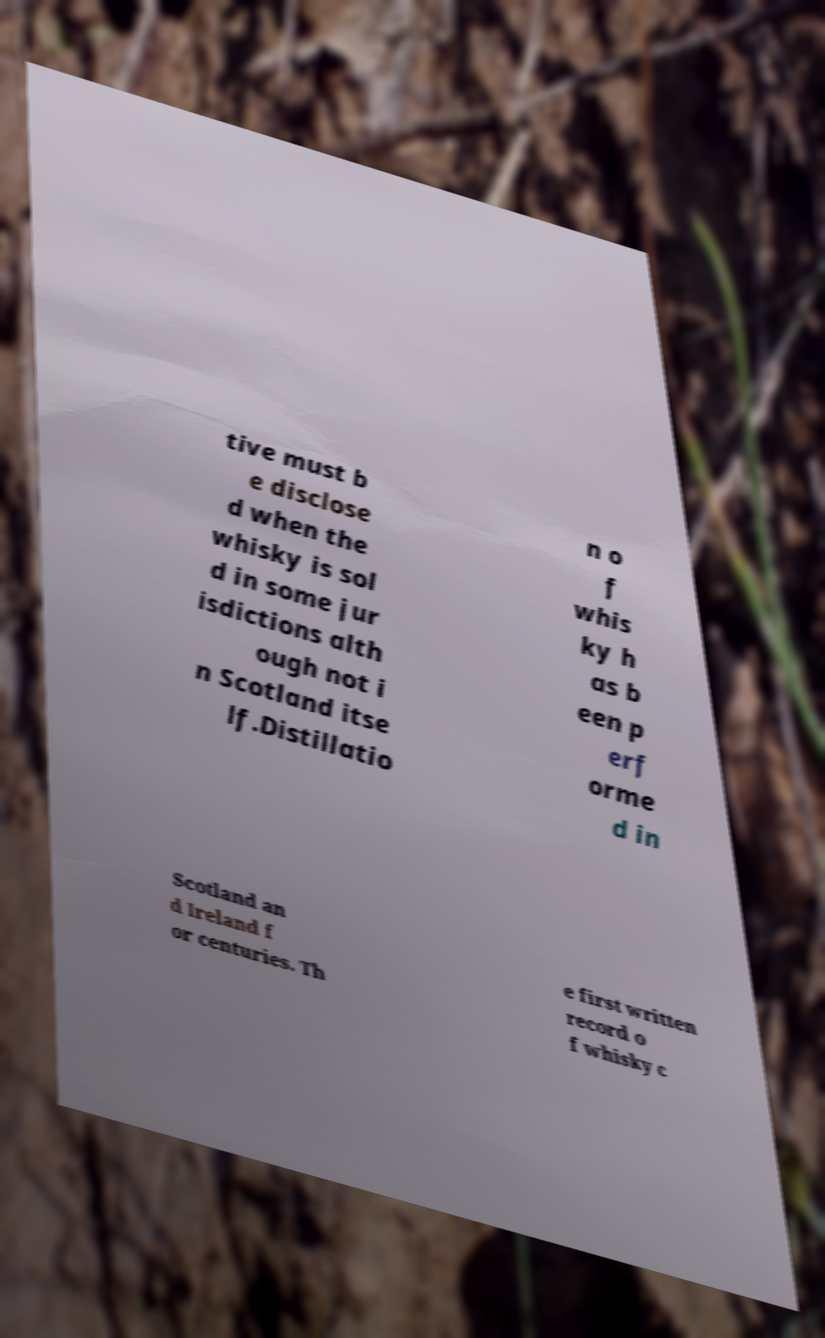Could you extract and type out the text from this image? tive must b e disclose d when the whisky is sol d in some jur isdictions alth ough not i n Scotland itse lf.Distillatio n o f whis ky h as b een p erf orme d in Scotland an d Ireland f or centuries. Th e first written record o f whisky c 